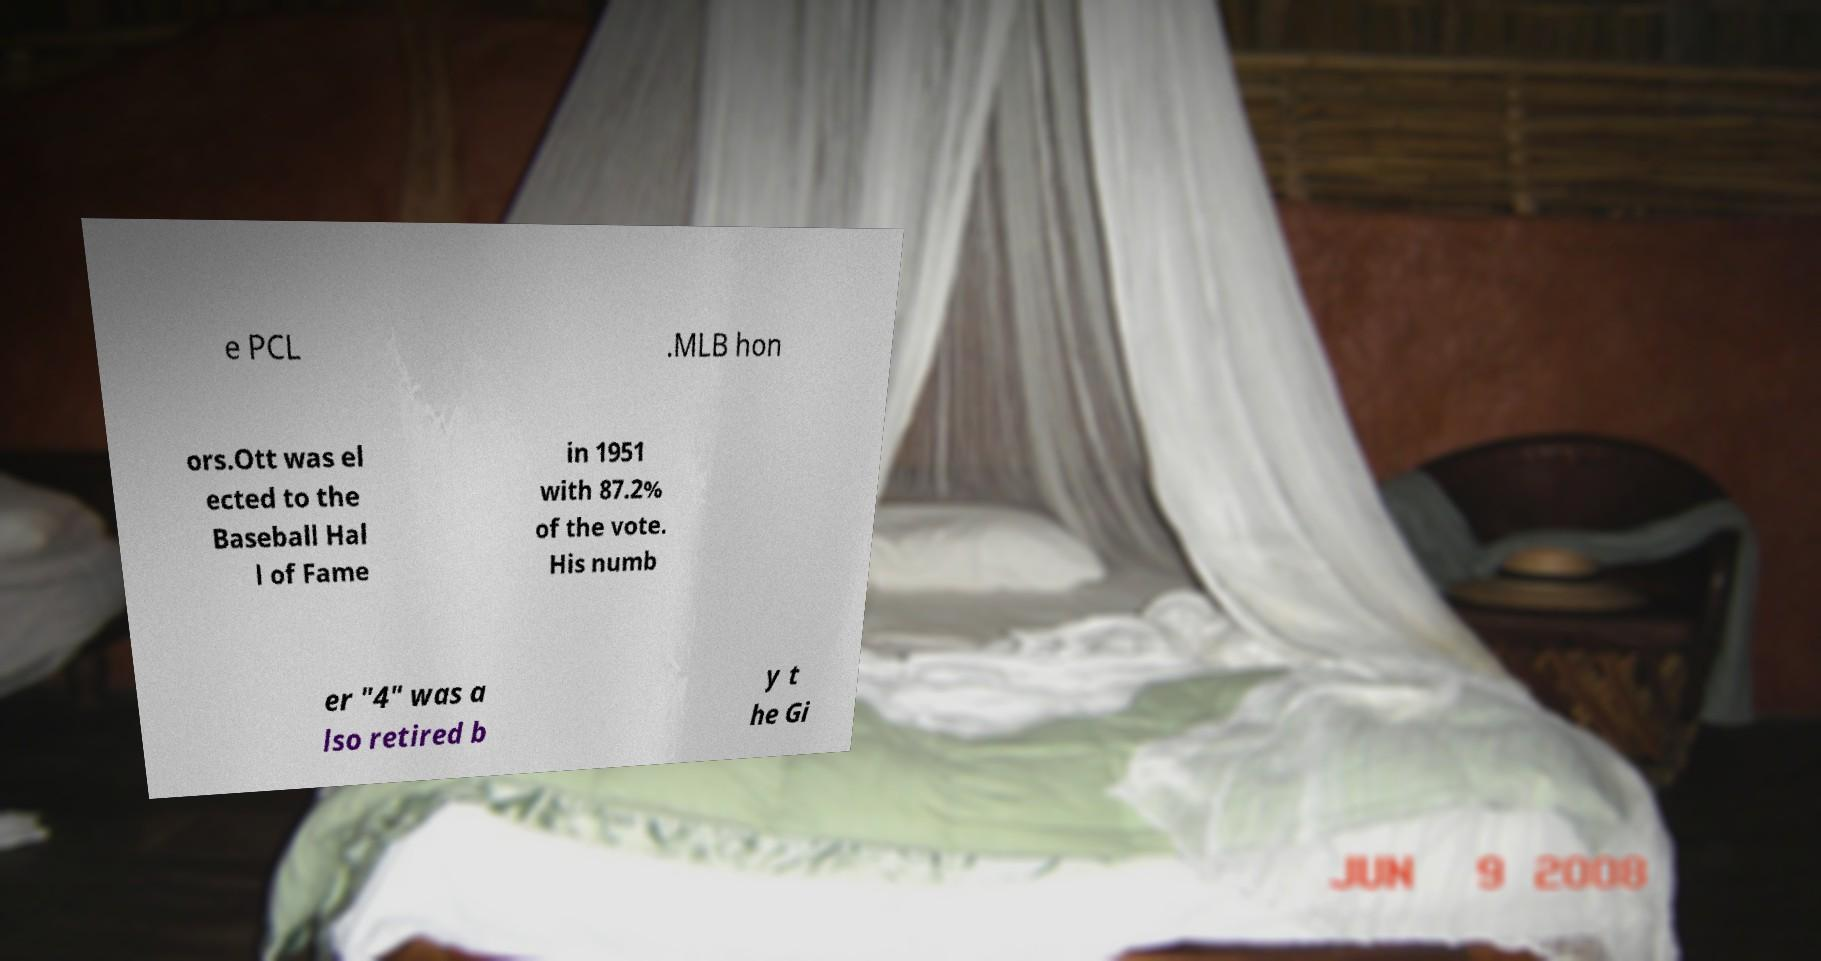I need the written content from this picture converted into text. Can you do that? e PCL .MLB hon ors.Ott was el ected to the Baseball Hal l of Fame in 1951 with 87.2% of the vote. His numb er "4" was a lso retired b y t he Gi 